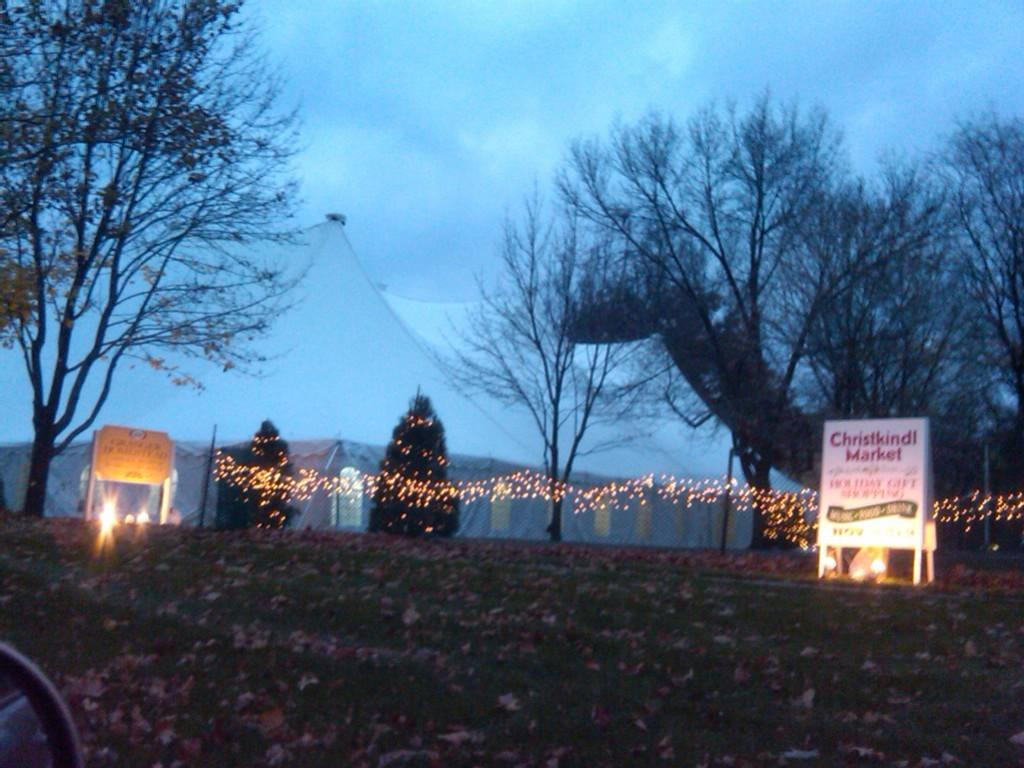What type of vegetation can be seen in the image? There is grass in the image. What else can be found on the ground in the image? Dried leaves are present in the image. What structures are visible in the image? There are boards, lights, poles, tents, and trees in the image. What is visible in the background of the image? The sky is visible in the background of the image. What can be seen in the sky? Clouds are present in the sky. What type of soup is being served in the image? There is no soup present in the image. What unit of measurement is used to determine the size of the tents in the image? The size of the tents is not specified in the image, and no unit of measurement is mentioned. 